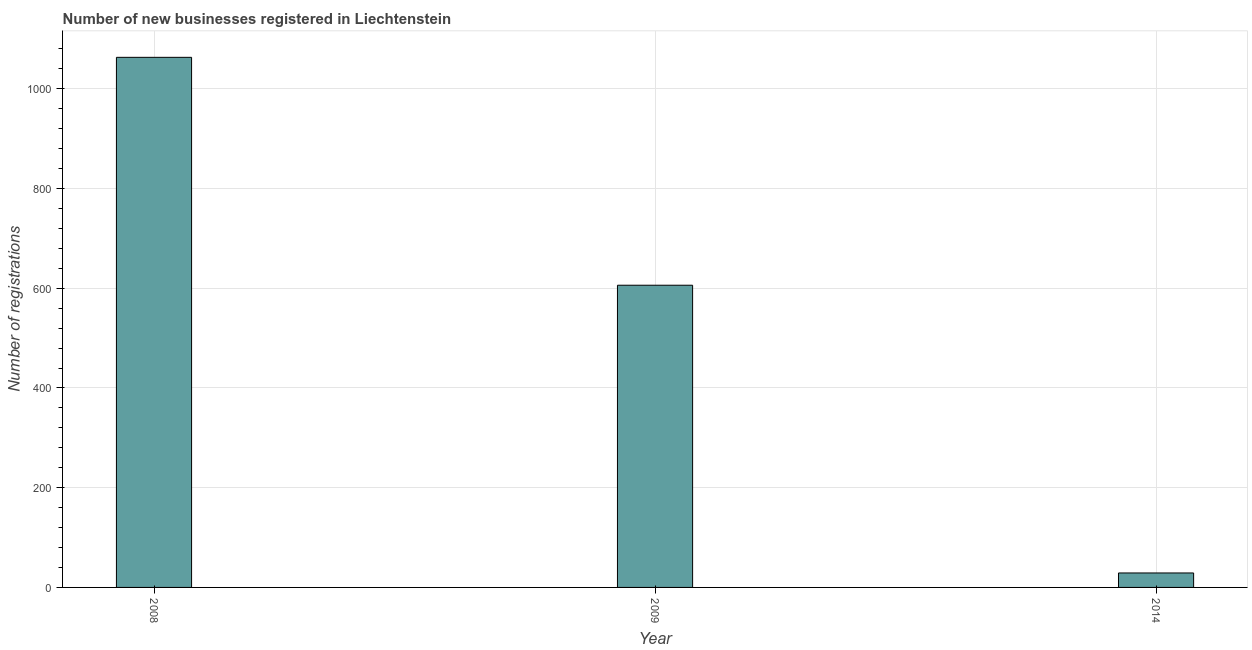Does the graph contain grids?
Give a very brief answer. Yes. What is the title of the graph?
Make the answer very short. Number of new businesses registered in Liechtenstein. What is the label or title of the X-axis?
Ensure brevity in your answer.  Year. What is the label or title of the Y-axis?
Your response must be concise. Number of registrations. What is the number of new business registrations in 2009?
Offer a terse response. 606. Across all years, what is the maximum number of new business registrations?
Ensure brevity in your answer.  1063. What is the sum of the number of new business registrations?
Your answer should be compact. 1698. What is the difference between the number of new business registrations in 2009 and 2014?
Keep it short and to the point. 577. What is the average number of new business registrations per year?
Offer a terse response. 566. What is the median number of new business registrations?
Provide a short and direct response. 606. In how many years, is the number of new business registrations greater than 400 ?
Provide a short and direct response. 2. What is the ratio of the number of new business registrations in 2008 to that in 2009?
Make the answer very short. 1.75. Is the number of new business registrations in 2008 less than that in 2009?
Provide a succinct answer. No. What is the difference between the highest and the second highest number of new business registrations?
Your answer should be very brief. 457. What is the difference between the highest and the lowest number of new business registrations?
Make the answer very short. 1034. In how many years, is the number of new business registrations greater than the average number of new business registrations taken over all years?
Make the answer very short. 2. Are all the bars in the graph horizontal?
Ensure brevity in your answer.  No. How many years are there in the graph?
Give a very brief answer. 3. Are the values on the major ticks of Y-axis written in scientific E-notation?
Ensure brevity in your answer.  No. What is the Number of registrations in 2008?
Keep it short and to the point. 1063. What is the Number of registrations of 2009?
Your answer should be very brief. 606. What is the difference between the Number of registrations in 2008 and 2009?
Your answer should be very brief. 457. What is the difference between the Number of registrations in 2008 and 2014?
Offer a terse response. 1034. What is the difference between the Number of registrations in 2009 and 2014?
Your answer should be very brief. 577. What is the ratio of the Number of registrations in 2008 to that in 2009?
Make the answer very short. 1.75. What is the ratio of the Number of registrations in 2008 to that in 2014?
Ensure brevity in your answer.  36.66. What is the ratio of the Number of registrations in 2009 to that in 2014?
Your answer should be compact. 20.9. 